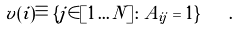<formula> <loc_0><loc_0><loc_500><loc_500>v ( i ) \equiv \{ j \in [ 1 \dots N ] \colon A _ { i j } = 1 \} \quad .</formula> 